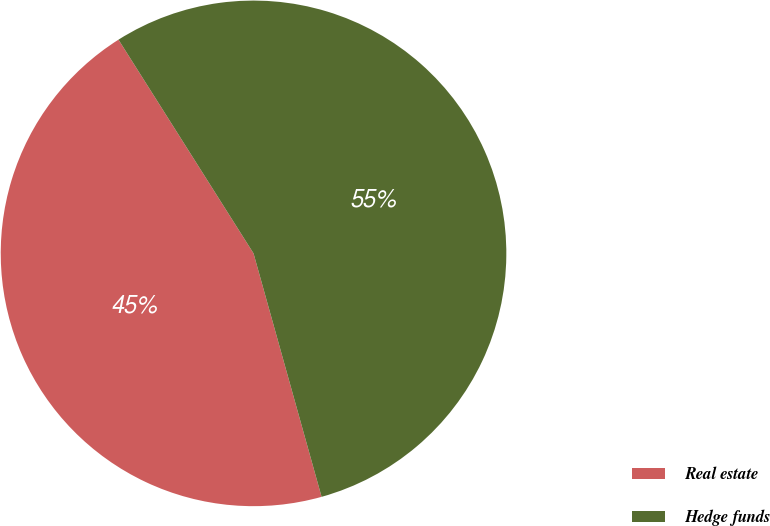<chart> <loc_0><loc_0><loc_500><loc_500><pie_chart><fcel>Real estate<fcel>Hedge funds<nl><fcel>45.37%<fcel>54.63%<nl></chart> 